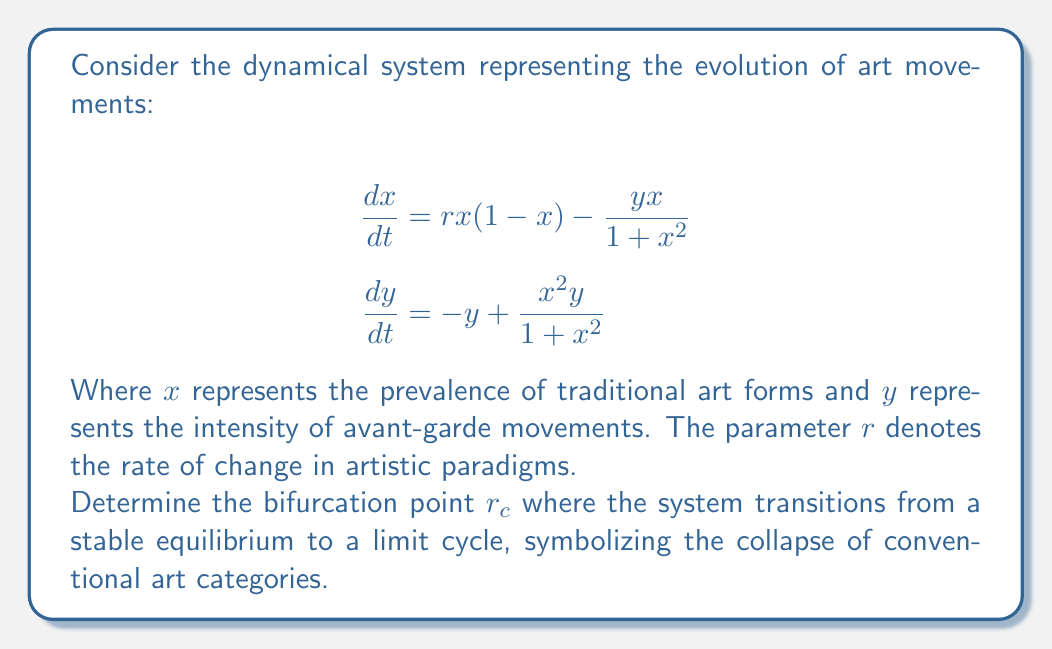Can you answer this question? To find the bifurcation point, we'll follow these steps:

1) First, find the equilibrium points by setting $\frac{dx}{dt} = \frac{dy}{dt} = 0$:

   $$rx(1-x) - \frac{yx}{1+x^2} = 0$$
   $$-y + \frac{x^2y}{1+x^2} = 0$$

2) From the second equation, we get $y = 0$ or $x = 1$.

3) If $y = 0$, the first equation becomes $rx(1-x) = 0$, giving $x = 0$ or $x = 1$.

4) The equilibrium points are $(0,0)$ and $(1,0)$.

5) To find the bifurcation point, we need to analyze the stability of these equilibria. Let's focus on $(1,0)$ as it represents a non-trivial state.

6) Calculate the Jacobian matrix at $(1,0)$:

   $$J = \begin{bmatrix}
   \frac{\partial}{\partial x}(rx(1-x) - \frac{yx}{1+x^2}) & \frac{\partial}{\partial y}(rx(1-x) - \frac{yx}{1+x^2}) \\
   \frac{\partial}{\partial x}(-y + \frac{x^2y}{1+x^2}) & \frac{\partial}{\partial y}(-y + \frac{x^2y}{1+x^2})
   \end{bmatrix}_{(1,0)}$$

7) Evaluating at $(1,0)$:

   $$J_{(1,0)} = \begin{bmatrix}
   -r & -\frac{1}{2} \\
   0 & -\frac{1}{2}
   \end{bmatrix}$$

8) The eigenvalues are $\lambda_1 = -r$ and $\lambda_2 = -\frac{1}{2}$.

9) The bifurcation occurs when the real part of an eigenvalue becomes positive. This happens when $r = 0$.

10) Therefore, the bifurcation point $r_c = 0$.

This bifurcation represents a transition from a stable equilibrium (traditional art forms) to a limit cycle (constant flux between traditional and avant-garde), symbolizing the collapse of conventional art categories.
Answer: $r_c = 0$ 